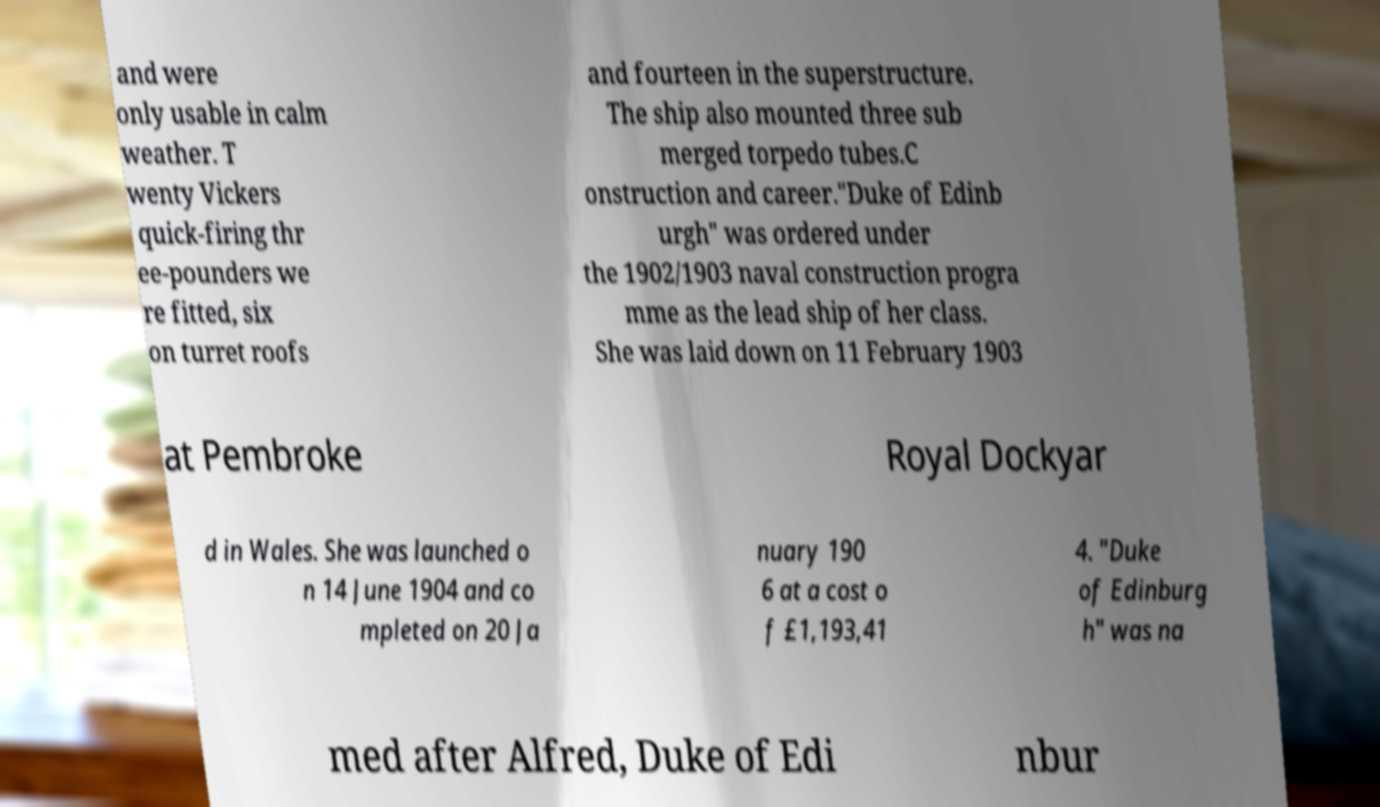Could you assist in decoding the text presented in this image and type it out clearly? and were only usable in calm weather. T wenty Vickers quick-firing thr ee-pounders we re fitted, six on turret roofs and fourteen in the superstructure. The ship also mounted three sub merged torpedo tubes.C onstruction and career."Duke of Edinb urgh" was ordered under the 1902/1903 naval construction progra mme as the lead ship of her class. She was laid down on 11 February 1903 at Pembroke Royal Dockyar d in Wales. She was launched o n 14 June 1904 and co mpleted on 20 Ja nuary 190 6 at a cost o f £1,193,41 4. "Duke of Edinburg h" was na med after Alfred, Duke of Edi nbur 